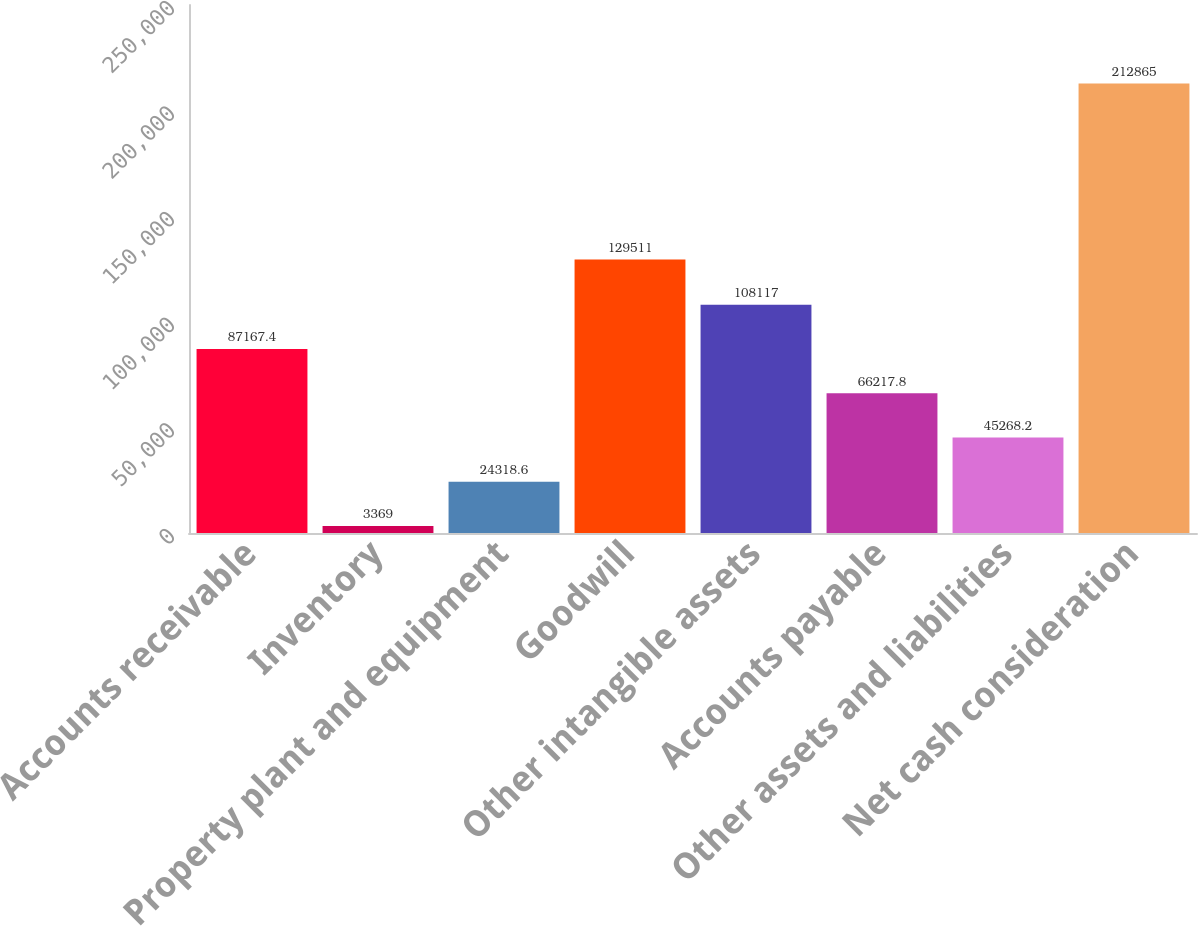Convert chart to OTSL. <chart><loc_0><loc_0><loc_500><loc_500><bar_chart><fcel>Accounts receivable<fcel>Inventory<fcel>Property plant and equipment<fcel>Goodwill<fcel>Other intangible assets<fcel>Accounts payable<fcel>Other assets and liabilities<fcel>Net cash consideration<nl><fcel>87167.4<fcel>3369<fcel>24318.6<fcel>129511<fcel>108117<fcel>66217.8<fcel>45268.2<fcel>212865<nl></chart> 